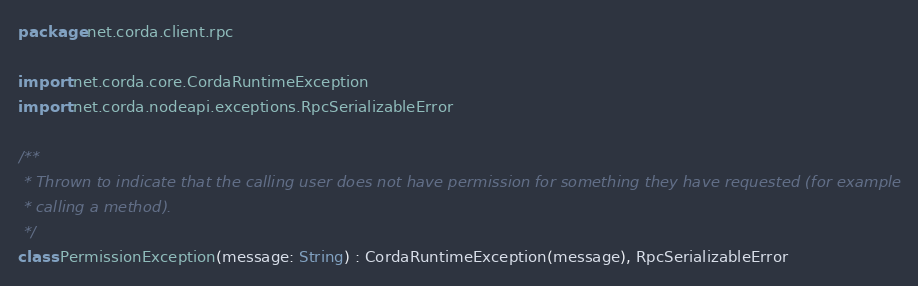Convert code to text. <code><loc_0><loc_0><loc_500><loc_500><_Kotlin_>package net.corda.client.rpc

import net.corda.core.CordaRuntimeException
import net.corda.nodeapi.exceptions.RpcSerializableError

/**
 * Thrown to indicate that the calling user does not have permission for something they have requested (for example
 * calling a method).
 */
class PermissionException(message: String) : CordaRuntimeException(message), RpcSerializableError
</code> 